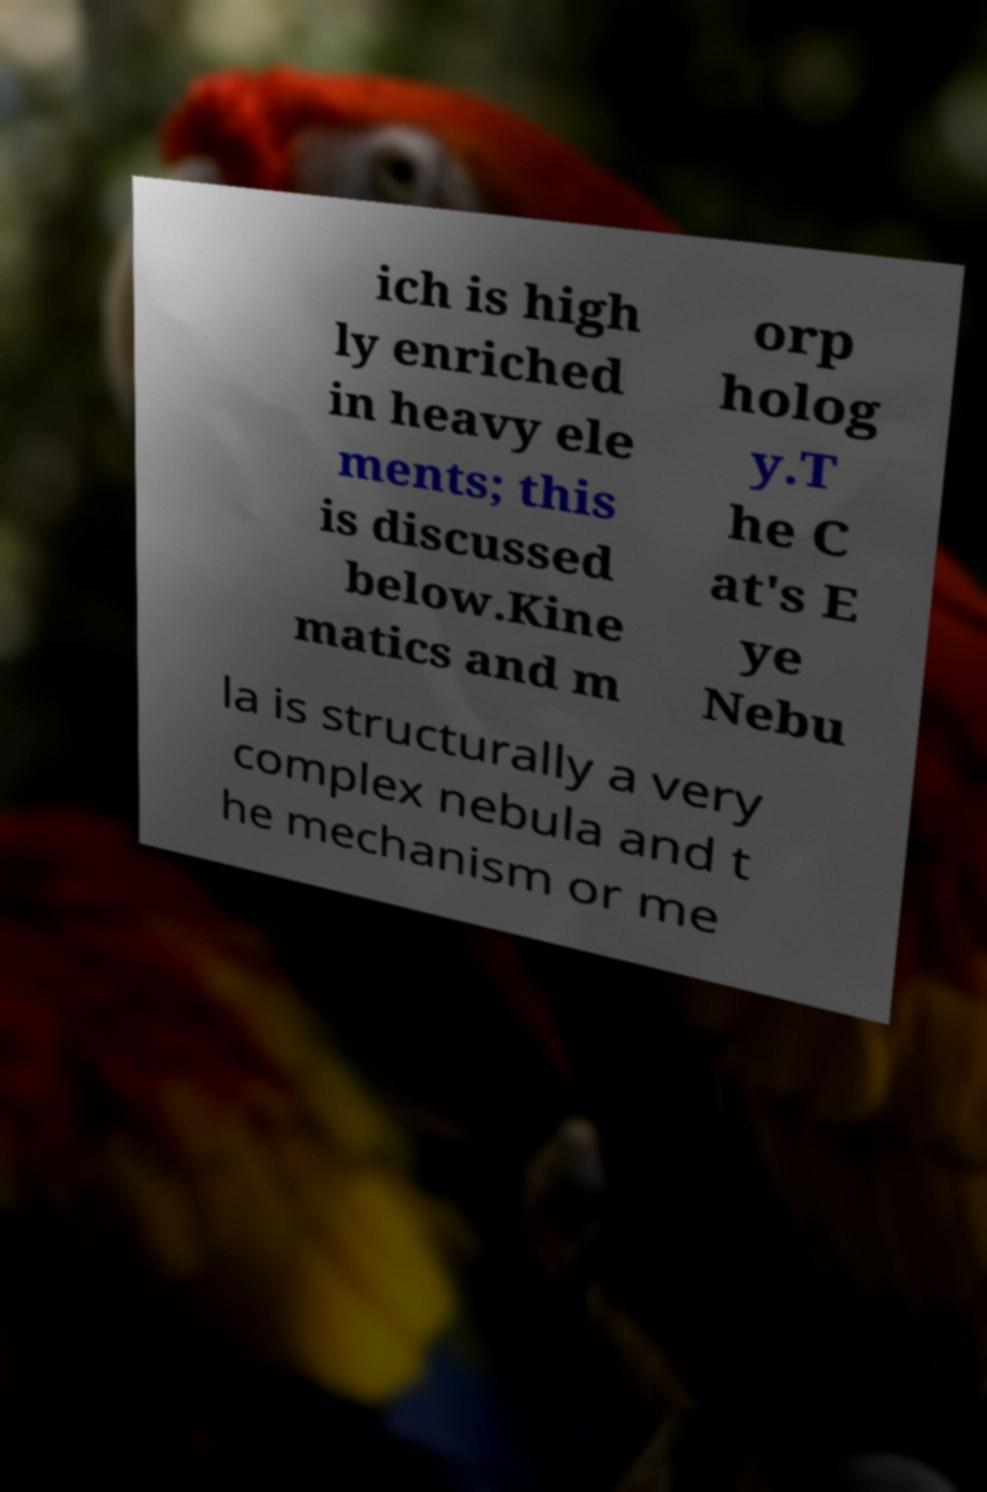What messages or text are displayed in this image? I need them in a readable, typed format. ich is high ly enriched in heavy ele ments; this is discussed below.Kine matics and m orp holog y.T he C at's E ye Nebu la is structurally a very complex nebula and t he mechanism or me 